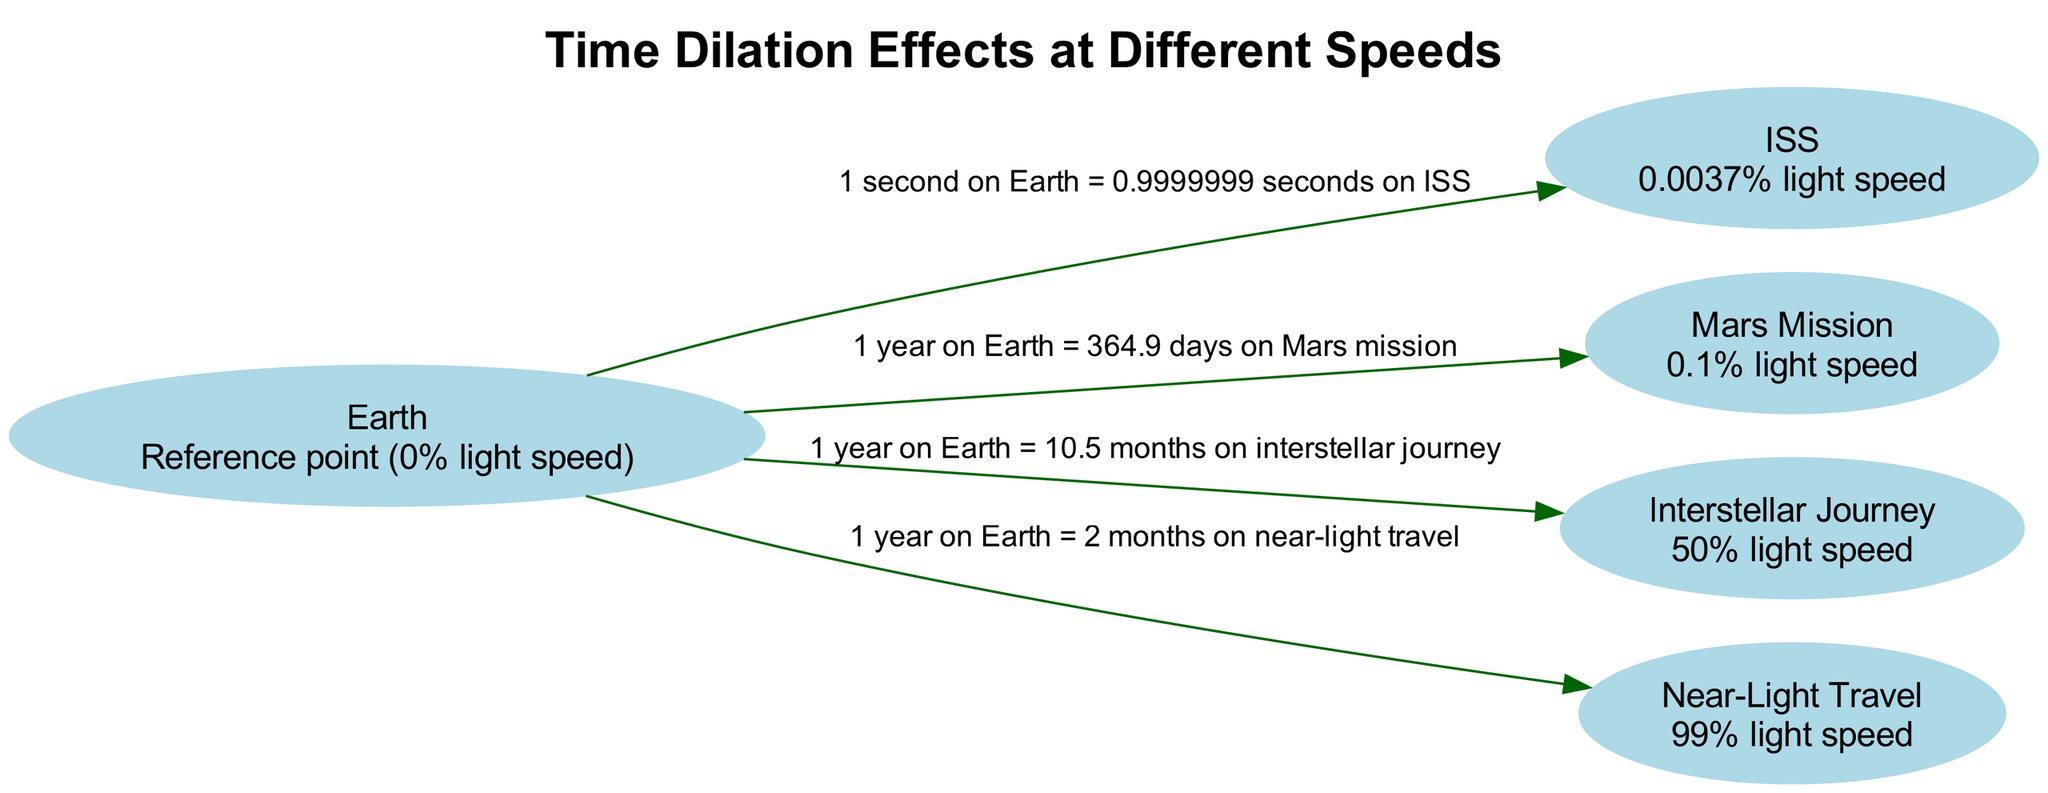What is the speed of the ISS relative to light? The diagram states that the speed of the ISS is 0.0037% of the speed of light, as indicated in the node description for the ISS.
Answer: 0.0037% light speed How long does 1 year on Earth equal in time dilation for the Mars Mission? The edge connecting Earth and the Mars Mission states that 1 year on Earth equals 364.9 days on the Mars Mission, illustrating the time dilation effect.
Answer: 364.9 days How many nodes are in the diagram? The diagram lists a total of five distinct nodes: Earth, ISS, Mars Mission, Interstellar Journey, and Near-Light Travel. Counting these gives us the total number of nodes.
Answer: 5 What is the relationship between Earth and Near-Light Travel? The edge from Earth to Near-Light Travel indicates that 1 year on Earth equals 2 months on Near-Light Travel, revealing the time dilation between these two points.
Answer: 1 year on Earth = 2 months on near-light travel Which speed has the greatest time dilation effect as shown on the diagram? The Near-Light Travel node represents the highest speed at 99% light speed, and the corresponding edge shows the most extreme time dilation effect of 1 year on Earth equating to only 2 months on near-light travel.
Answer: Near-Light Travel What is the total time experienced by an astronaut on an Interstellar Journey compared to Earth? The edge indicates that 1 year on Earth equals 10.5 months on an Interstellar Journey. To find the total time experienced in Earth years, we take 10.5 months and convert it to years, which is approximately 0.875 years.
Answer: 10.5 months Which two speeds have a speed percentage of less than 1% relative to light? The only two speeds indicated in the diagram with a percentage less than 1% are the ISS at 0.0037% light speed and the Mars Mission at 0.1% light speed.
Answer: ISS and Mars Mission What is the time ratio for one second on Earth in relation to the ISS? According to the edge from Earth to the ISS, 1 second on Earth is equal to 0.9999999 seconds on the ISS, highlighting the minuscule difference caused by time dilation at that speed.
Answer: 0.9999999 seconds on ISS How is the time comparison between Earth and Interstellar Journey described? The edge provides a clear relationship that states 1 year on Earth equals 10.5 months on an interstellar journey, demonstrating the effect of traveling at a significant fraction of light speed.
Answer: 1 year on Earth = 10.5 months on interstellar journey 